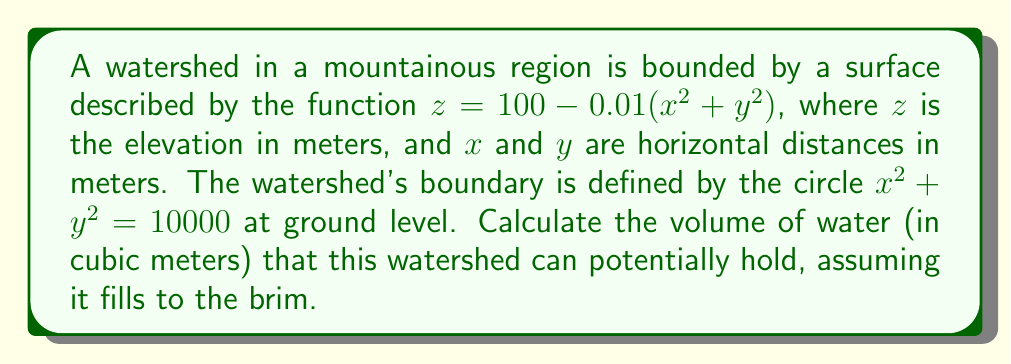What is the answer to this math problem? To solve this problem, we'll use a triple integral to calculate the volume between the ground level (z = 0) and the surface of the watershed. We'll parameterize the surface using cylindrical coordinates for easier integration.

Step 1: Convert to cylindrical coordinates
$x = r \cos(\theta)$
$y = r \sin(\theta)$
$z = 100 - 0.01r^2$

Step 2: Set up the triple integral
The volume is given by:

$$V = \iiint_D dV = \int_0^{2\pi} \int_0^{100} \int_0^{100-0.01r^2} r \, dz \, dr \, d\theta$$

Step 3: Evaluate the innermost integral (with respect to z)
$$\int_0^{100-0.01r^2} dz = [z]_0^{100-0.01r^2} = 100 - 0.01r^2$$

Step 4: Evaluate the middle integral (with respect to r)
$$\int_0^{100} r(100 - 0.01r^2) \, dr = \int_0^{100} (100r - 0.01r^3) \, dr$$
$$= [50r^2 - 0.0025r^4]_0^{100} = 500000 - 250000 = 250000$$

Step 5: Evaluate the outermost integral (with respect to θ)
$$\int_0^{2\pi} 250000 \, d\theta = 250000 [θ]_0^{2\pi} = 500000\pi$$

Therefore, the volume of the watershed is $500000\pi$ cubic meters.
Answer: $500000\pi$ m³ 